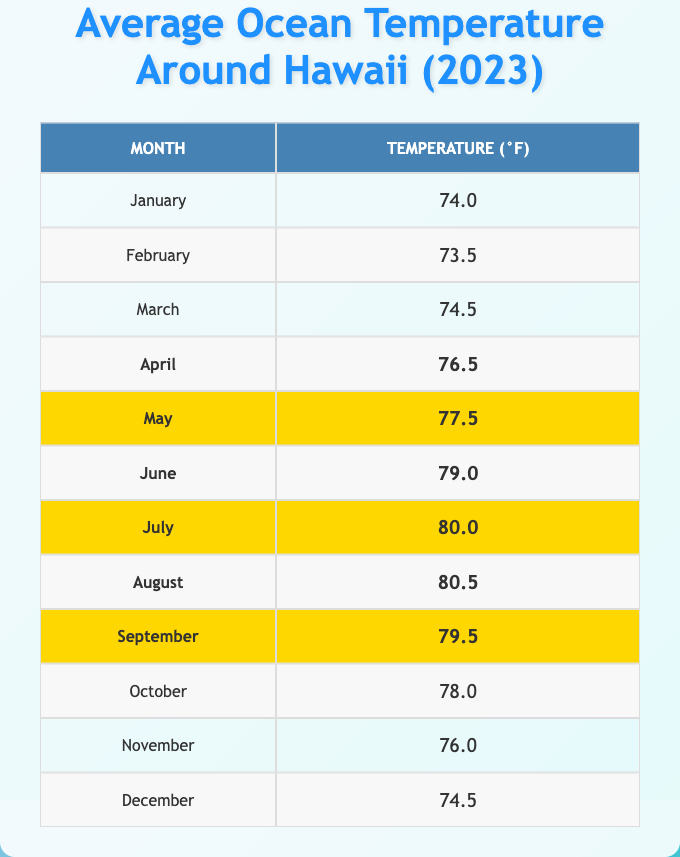What is the highest average ocean temperature in Hawaii for 2023? The table shows the average ocean temperatures for each month. By inspecting the values, July has the highest temperature at 80.0°F.
Answer: 80.0°F Which month recorded the lowest average ocean temperature? The table lists 73.5°F for February as the lowest average ocean temperature in Hawaii for 2023.
Answer: February How many months had an average ocean temperature above 78°F? From the highlighted months (April to September), five months show temperatures above 78°F: April (76.5°F does not count), May (77.5°F does not count), June (79.0°F), July (80.0°F), August (80.5°F), and September (79.5°F). Therefore, four months qualify.
Answer: Four months What was the average ocean temperature for the highlighted months? The highlighted months with their temperatures are April (76.5°F), May (77.5°F), June (79.0°F), July (80.0°F), August (80.5°F), and September (79.5°F). Sum these temperatures: 76.5 + 77.5 + 79.0 + 80.0 + 80.5 + 79.5 = 473.0°F. There are 6 months, so the average is 473.0 / 6 = 78.83°F.
Answer: 78.83°F In which month(s) is the ocean temperature at least 78°F? By checking the temperatures, the months that have temperatures of 78°F or higher are June (79.0°F), July (80.0°F), August (80.5°F), and September (79.5°F).
Answer: June, July, August, September Is there any month with an average temperature of exactly 78°F? Looking at the table, there are no months listed with an average ocean temperature of 78°F. The closest values are 77.5°F (May) and 78.0°F (October).
Answer: No What is the temperature difference between the hottest and coldest month in 2023? The hottest month is July at 80.0°F and the coldest month is February at 73.5°F. The temperature difference is 80.0 - 73.5 = 6.5°F.
Answer: 6.5°F Which month has a temperature less than 75°F? Referring to the table, January (74.0°F) and February (73.5°F) are the only months with temperatures below 75°F.
Answer: January, February How many months in total had an average temperature below 76°F? The months below 76°F are January (74.0°F), February (73.5°F), and March (74.5°F). That totals three months.
Answer: Three months What is the sum of the average ocean temperatures for the first three months? The average temperatures for January (74.0°F), February (73.5°F), and March (74.5°F) sum up to 74.0 + 73.5 + 74.5 = 222.0°F.
Answer: 222.0°F 